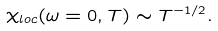Convert formula to latex. <formula><loc_0><loc_0><loc_500><loc_500>\chi _ { l o c } ( \omega = 0 , T ) \sim T ^ { - 1 / 2 } .</formula> 